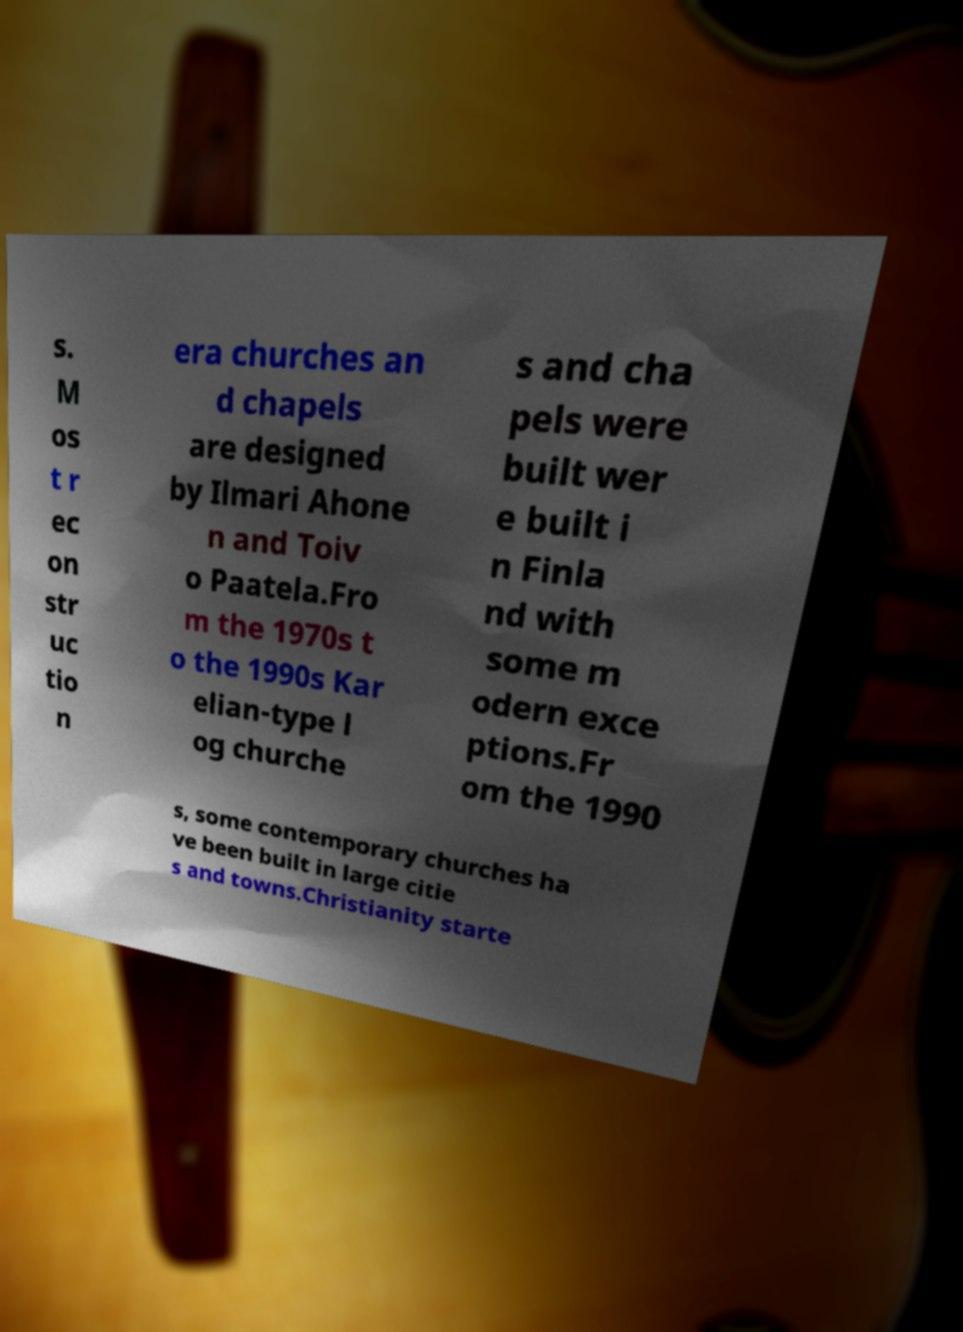I need the written content from this picture converted into text. Can you do that? s. M os t r ec on str uc tio n era churches an d chapels are designed by Ilmari Ahone n and Toiv o Paatela.Fro m the 1970s t o the 1990s Kar elian-type l og churche s and cha pels were built wer e built i n Finla nd with some m odern exce ptions.Fr om the 1990 s, some contemporary churches ha ve been built in large citie s and towns.Christianity starte 